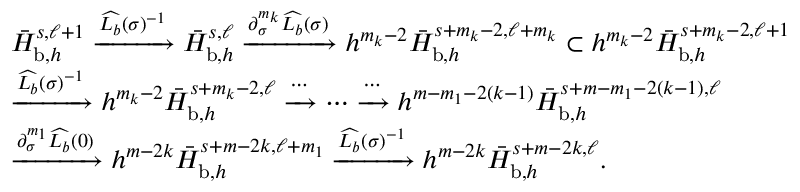Convert formula to latex. <formula><loc_0><loc_0><loc_500><loc_500>\begin{array} { r l } & { \bar { H } _ { b , h } ^ { s , \ell + 1 } \xrightarrow { \widehat { L _ { b } } ( \sigma ) ^ { - 1 } } \bar { H } _ { b , h } ^ { s , \ell } \xrightarrow { \partial _ { \sigma } ^ { m _ { k } } \widehat { L _ { b } } ( \sigma ) } h ^ { m _ { k } - 2 } \bar { H } _ { b , h } ^ { s + m _ { k } - 2 , \ell + m _ { k } } \subset h ^ { m _ { k } - 2 } \bar { H } _ { b , h } ^ { s + m _ { k } - 2 , \ell + 1 } } \\ & { \xrightarrow { \widehat { L _ { b } } ( \sigma ) ^ { - 1 } } h ^ { m _ { k } - 2 } \bar { H } _ { b , h } ^ { s + m _ { k } - 2 , \ell } \xrightarrow { \cdots } \cdots \xrightarrow { \cdots } h ^ { m - m _ { 1 } - 2 ( k - 1 ) } \bar { H } _ { b , h } ^ { s + m - m _ { 1 } - 2 ( k - 1 ) , \ell } } \\ & { \xrightarrow { \partial _ { \sigma } ^ { m _ { 1 } } \widehat { L _ { b } } ( 0 ) } h ^ { m - 2 k } \bar { H } _ { b , h } ^ { s + m - 2 k , \ell + m _ { 1 } } \xrightarrow { \widehat { L _ { b } } ( \sigma ) ^ { - 1 } } h ^ { m - 2 k } \bar { H } _ { b , h } ^ { s + m - 2 k , \ell } . } \end{array}</formula> 